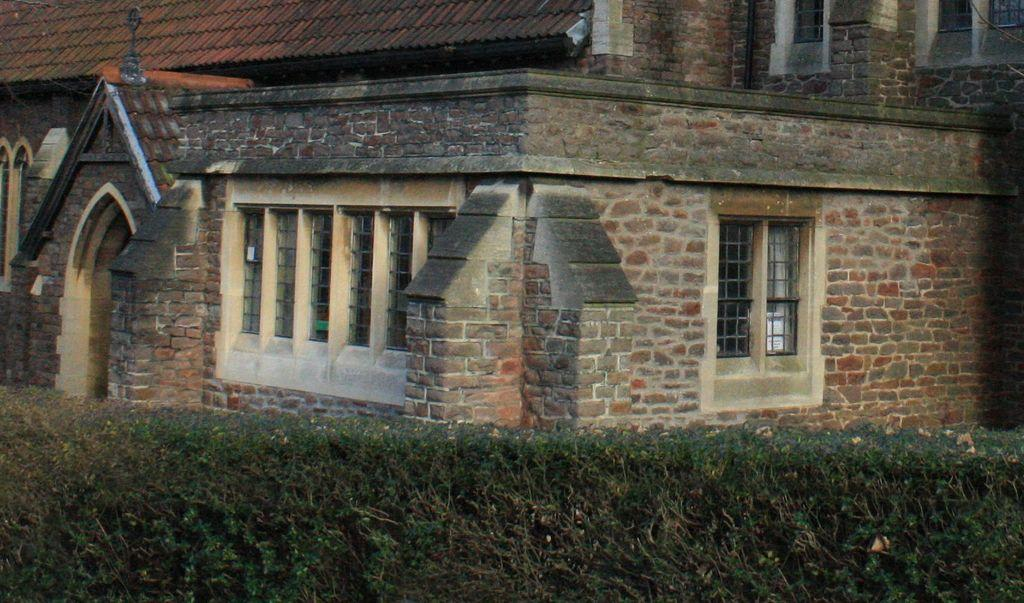What type of structure is visible in the image? There is a building in the image. What are the main features of the building? The building has a door and windows. What is located at the bottom of the image? There is a hedge at the bottom of the image. What is the texture of the development in the image? There is no development mentioned in the image, and therefore no texture can be determined. 